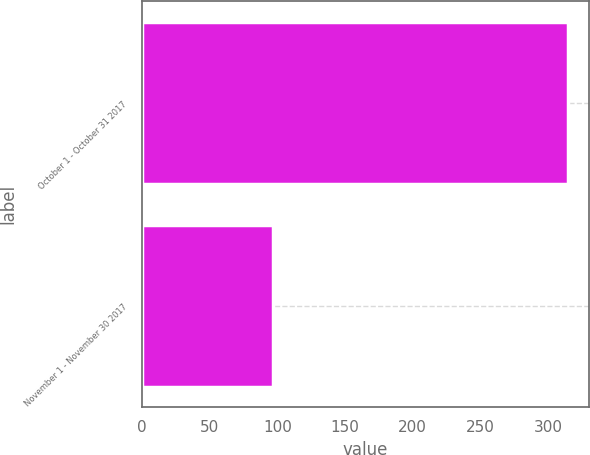Convert chart. <chart><loc_0><loc_0><loc_500><loc_500><bar_chart><fcel>October 1 - October 31 2017<fcel>November 1 - November 30 2017<nl><fcel>314.7<fcel>97<nl></chart> 